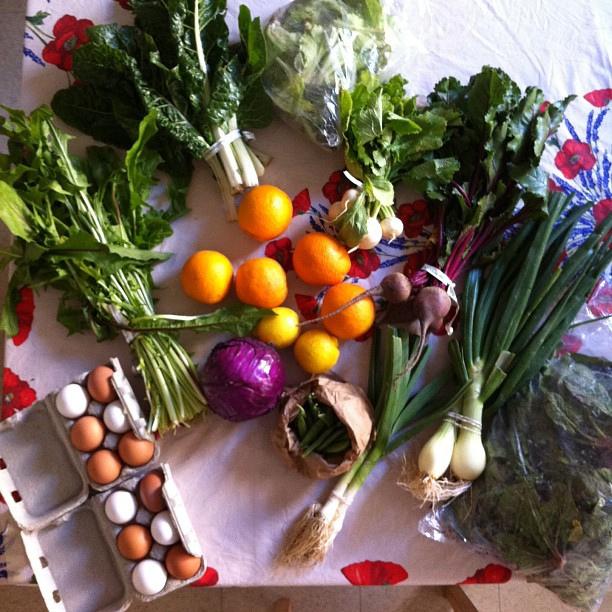What are the purple objects?
Quick response, please. Onions. Are half the eggs brown?
Quick response, please. Yes. What vegetables are displayed?
Quick response, please. Onions. How many brown eggs are there?
Give a very brief answer. 7. Where are the vegetables located?
Be succinct. Table. 